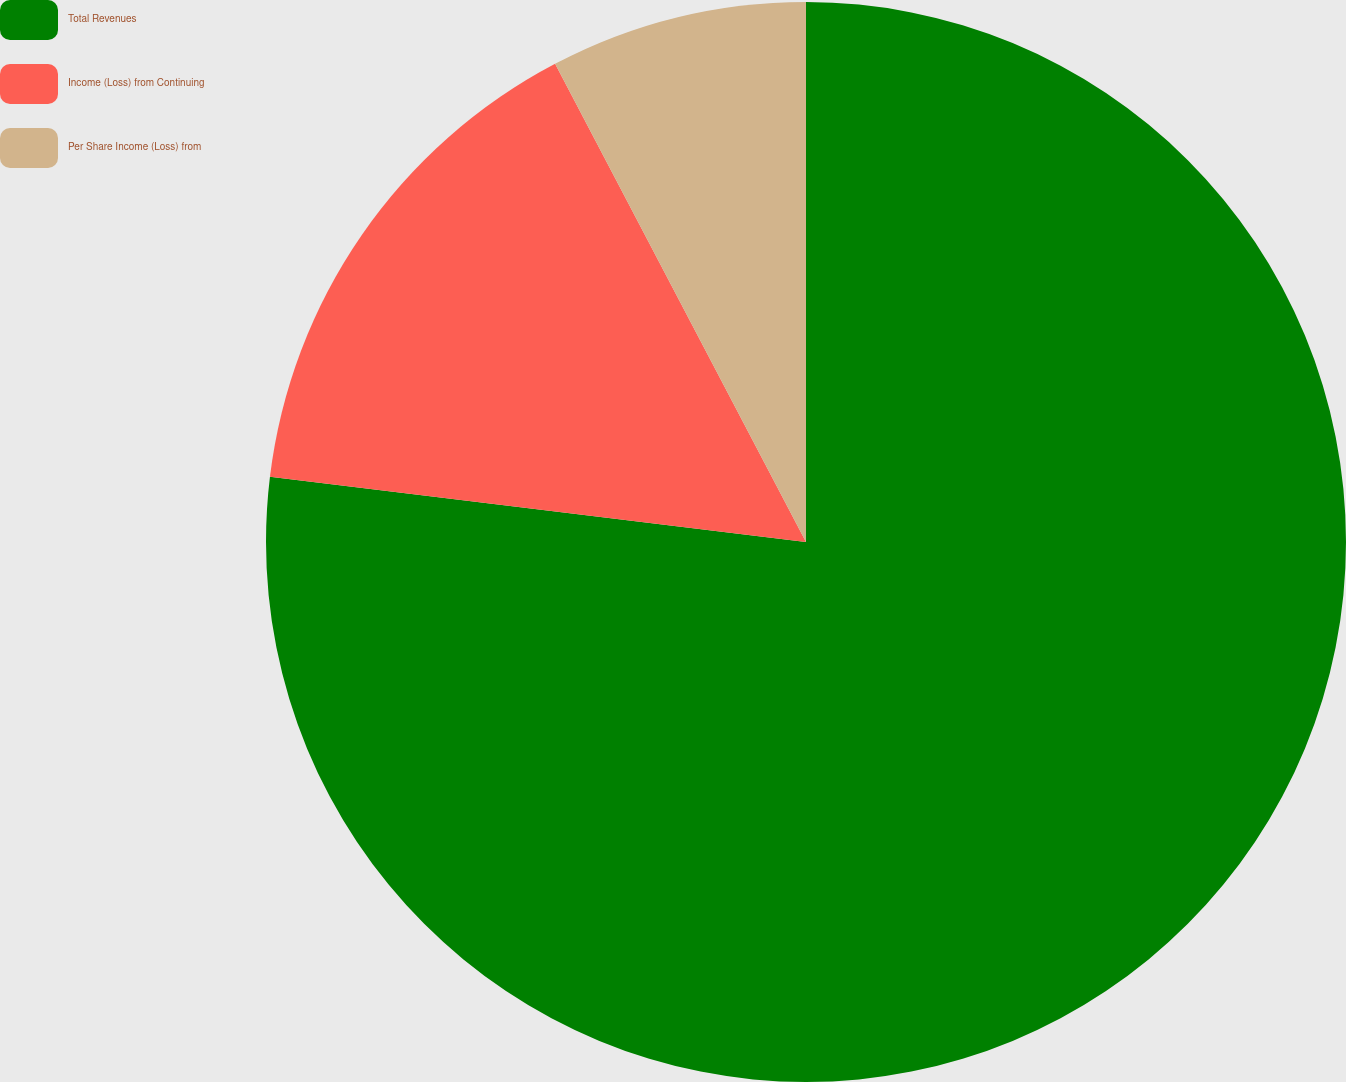<chart> <loc_0><loc_0><loc_500><loc_500><pie_chart><fcel>Total Revenues<fcel>Income (Loss) from Continuing<fcel>Per Share Income (Loss) from<nl><fcel>76.92%<fcel>15.38%<fcel>7.69%<nl></chart> 